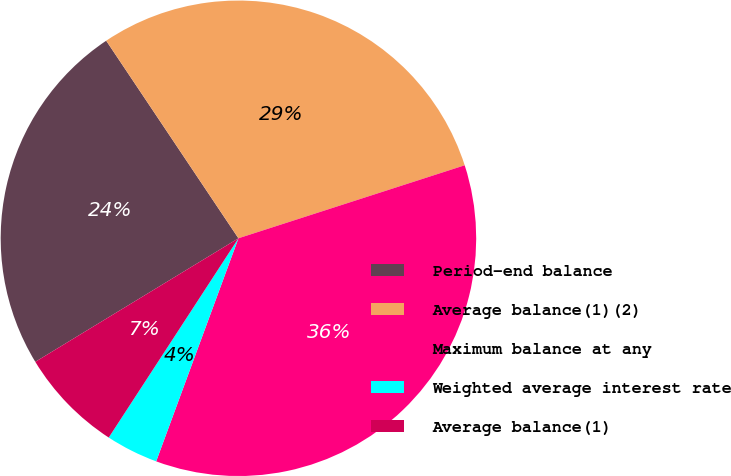<chart> <loc_0><loc_0><loc_500><loc_500><pie_chart><fcel>Period-end balance<fcel>Average balance(1)(2)<fcel>Maximum balance at any<fcel>Weighted average interest rate<fcel>Average balance(1)<nl><fcel>24.31%<fcel>29.42%<fcel>35.59%<fcel>3.56%<fcel>7.12%<nl></chart> 